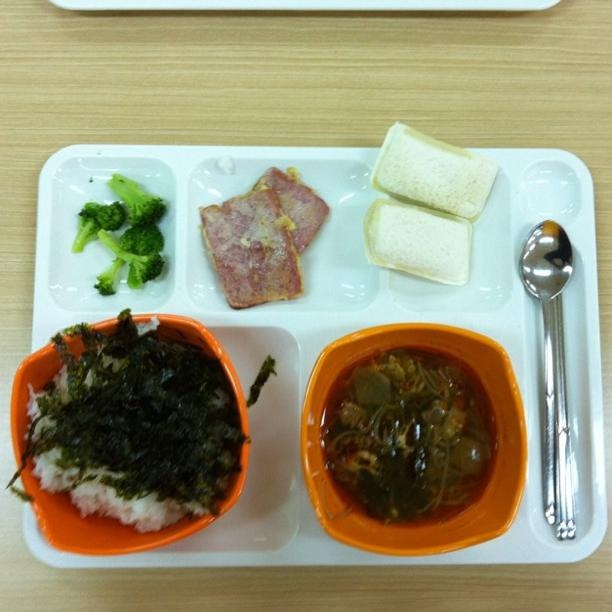Describe the objects in this image and their specific colors. I can see dining table in lightblue, tan, and black tones, bowl in tan, black, maroon, brown, and red tones, bowl in tan, black, maroon, and brown tones, broccoli in tan, darkgreen, and green tones, and spoon in tan, gray, white, darkgray, and black tones in this image. 